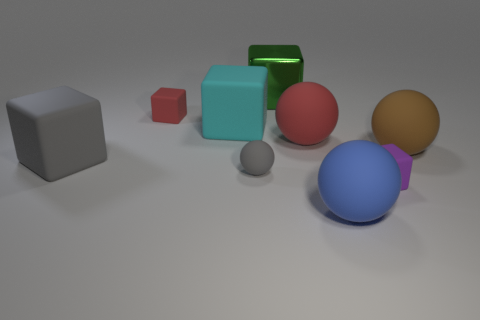How many spheres are red shiny things or large brown things?
Provide a succinct answer. 1. The metal cube that is the same size as the brown object is what color?
Offer a very short reply. Green. How many large spheres are both behind the brown rubber ball and in front of the brown thing?
Your answer should be compact. 0. What is the large cyan object made of?
Offer a very short reply. Rubber. What number of things are either green rubber balls or large cyan rubber objects?
Provide a short and direct response. 1. There is a sphere behind the large brown matte thing; is its size the same as the matte block that is on the right side of the large metal cube?
Your answer should be very brief. No. How many other things are the same size as the blue ball?
Give a very brief answer. 5. How many things are tiny matte blocks that are on the right side of the green metallic object or large metal objects that are on the right side of the big cyan matte object?
Your answer should be very brief. 2. Does the gray block have the same material as the sphere on the right side of the blue rubber thing?
Your answer should be very brief. Yes. How many other objects are the same shape as the small red object?
Give a very brief answer. 4. 